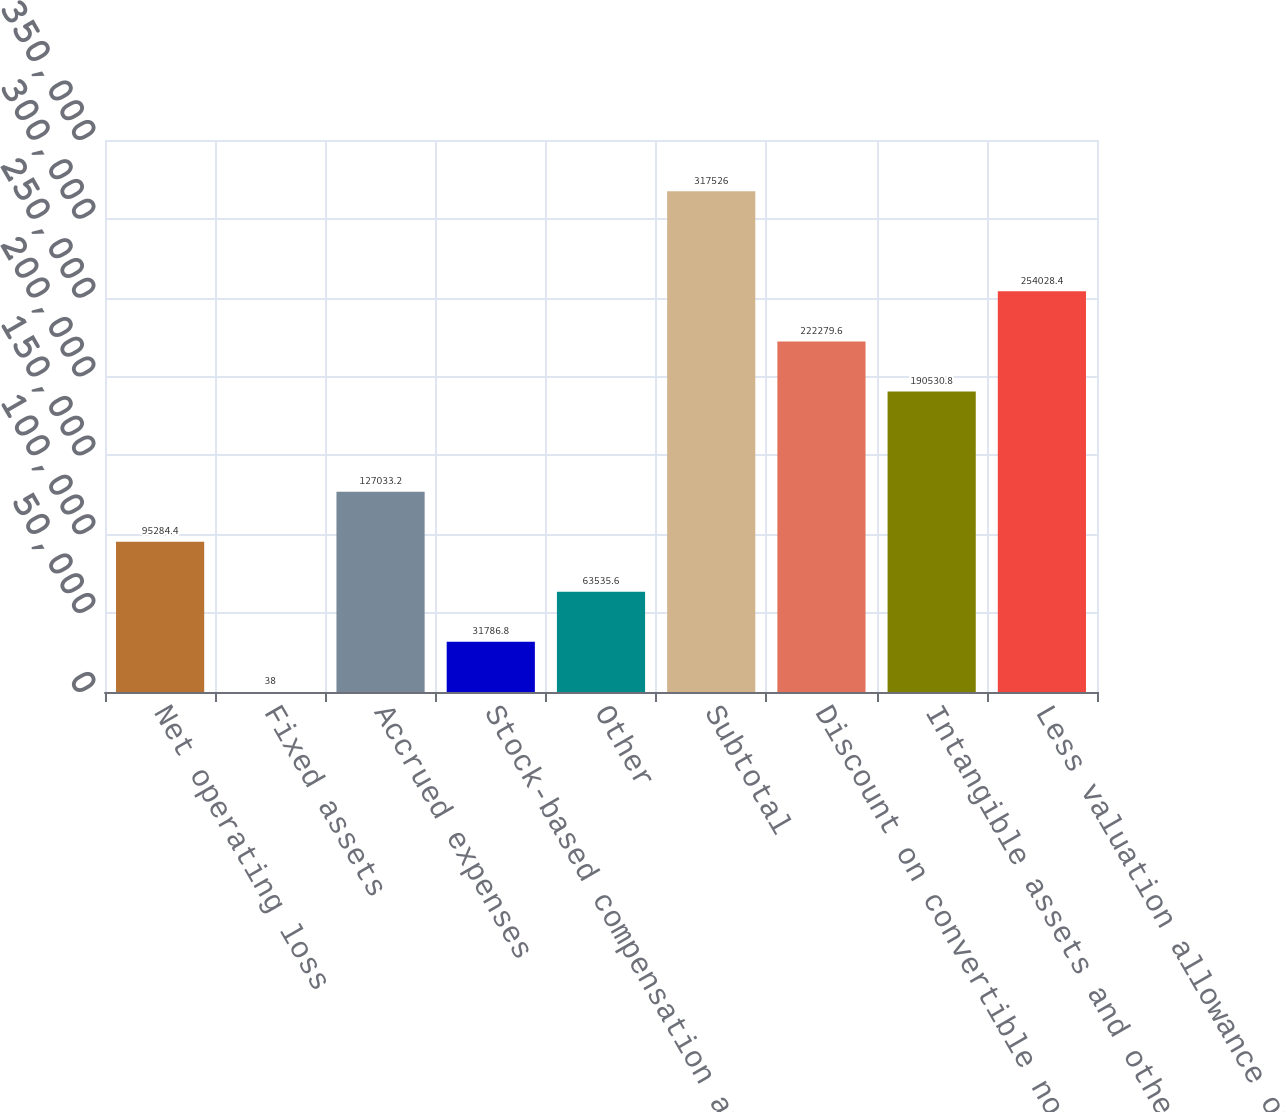<chart> <loc_0><loc_0><loc_500><loc_500><bar_chart><fcel>Net operating loss<fcel>Fixed assets<fcel>Accrued expenses<fcel>Stock-based compensation and<fcel>Other<fcel>Subtotal<fcel>Discount on convertible notes<fcel>Intangible assets and other<fcel>Less valuation allowance on<nl><fcel>95284.4<fcel>38<fcel>127033<fcel>31786.8<fcel>63535.6<fcel>317526<fcel>222280<fcel>190531<fcel>254028<nl></chart> 